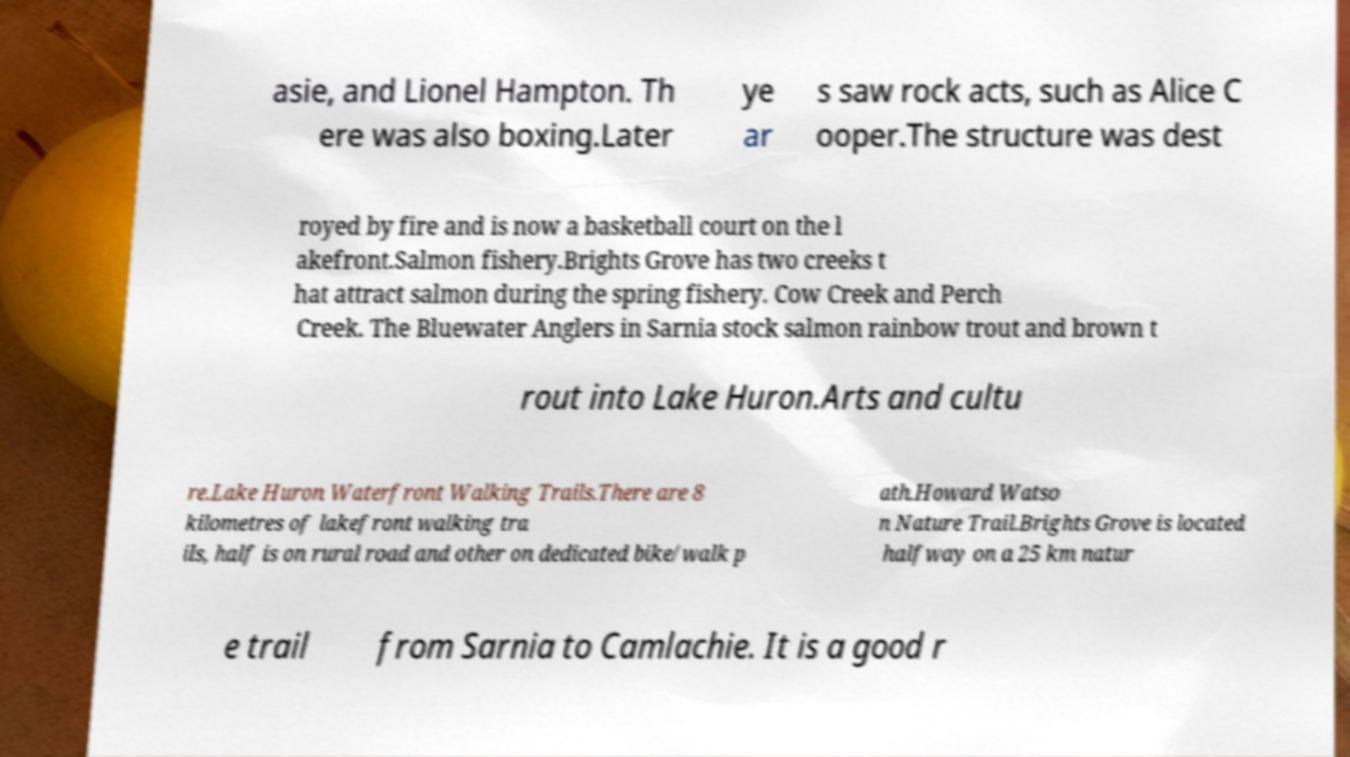Could you extract and type out the text from this image? asie, and Lionel Hampton. Th ere was also boxing.Later ye ar s saw rock acts, such as Alice C ooper.The structure was dest royed by fire and is now a basketball court on the l akefront.Salmon fishery.Brights Grove has two creeks t hat attract salmon during the spring fishery. Cow Creek and Perch Creek. The Bluewater Anglers in Sarnia stock salmon rainbow trout and brown t rout into Lake Huron.Arts and cultu re.Lake Huron Waterfront Walking Trails.There are 8 kilometres of lakefront walking tra ils, half is on rural road and other on dedicated bike/walk p ath.Howard Watso n Nature Trail.Brights Grove is located halfway on a 25 km natur e trail from Sarnia to Camlachie. It is a good r 